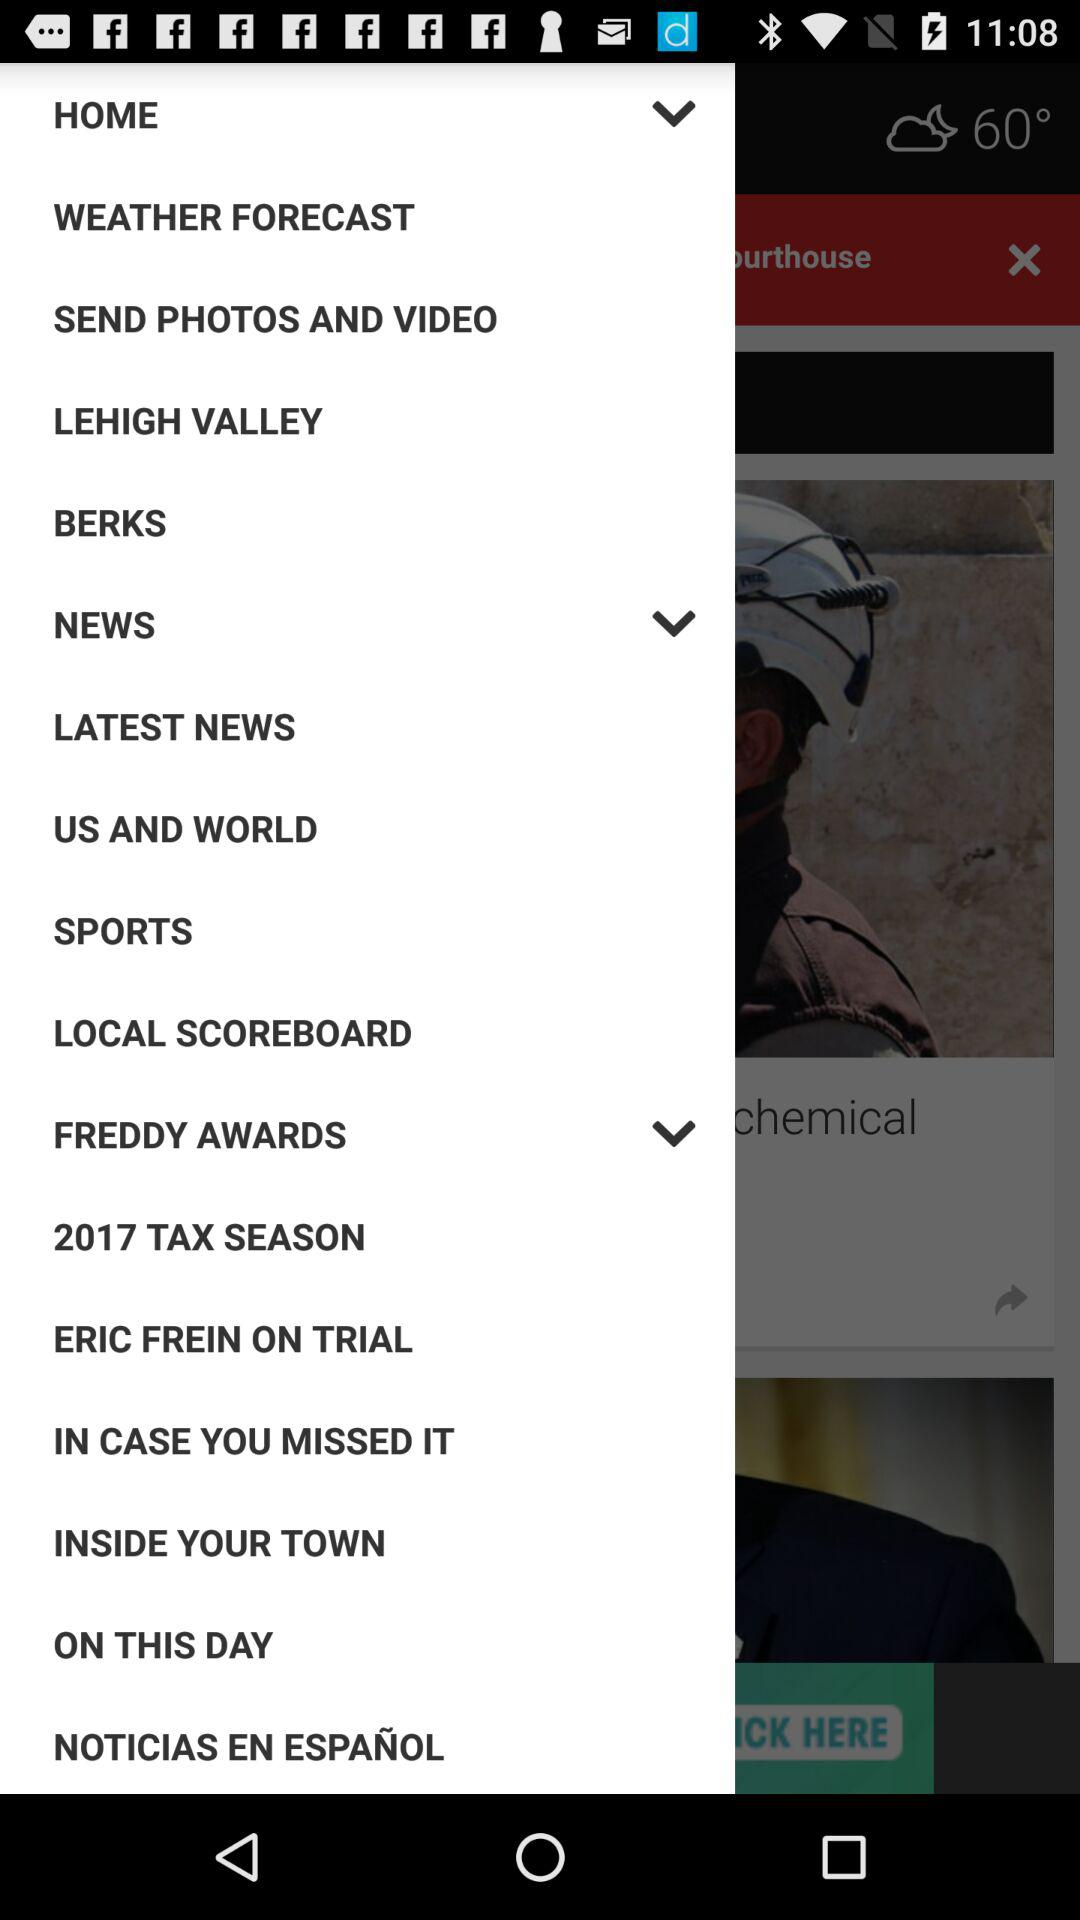Which year's tax season is there? The year is 2017. 